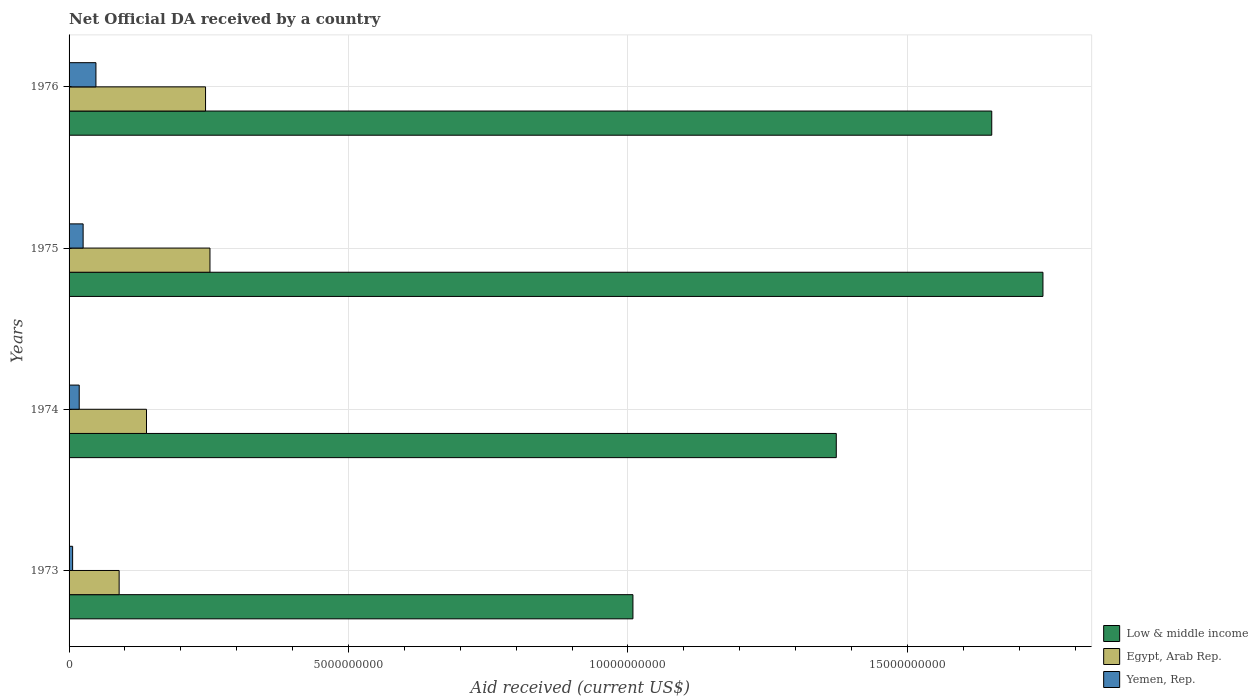How many different coloured bars are there?
Ensure brevity in your answer.  3. How many groups of bars are there?
Keep it short and to the point. 4. Are the number of bars per tick equal to the number of legend labels?
Offer a terse response. Yes. How many bars are there on the 4th tick from the bottom?
Keep it short and to the point. 3. What is the label of the 4th group of bars from the top?
Give a very brief answer. 1973. What is the net official development assistance aid received in Low & middle income in 1975?
Offer a terse response. 1.74e+1. Across all years, what is the maximum net official development assistance aid received in Egypt, Arab Rep.?
Provide a succinct answer. 2.52e+09. Across all years, what is the minimum net official development assistance aid received in Low & middle income?
Provide a short and direct response. 1.01e+1. In which year was the net official development assistance aid received in Egypt, Arab Rep. maximum?
Offer a very short reply. 1975. In which year was the net official development assistance aid received in Egypt, Arab Rep. minimum?
Provide a short and direct response. 1973. What is the total net official development assistance aid received in Low & middle income in the graph?
Ensure brevity in your answer.  5.77e+1. What is the difference between the net official development assistance aid received in Yemen, Rep. in 1974 and that in 1976?
Give a very brief answer. -2.99e+08. What is the difference between the net official development assistance aid received in Egypt, Arab Rep. in 1973 and the net official development assistance aid received in Low & middle income in 1976?
Provide a short and direct response. -1.56e+1. What is the average net official development assistance aid received in Egypt, Arab Rep. per year?
Your answer should be very brief. 1.81e+09. In the year 1973, what is the difference between the net official development assistance aid received in Egypt, Arab Rep. and net official development assistance aid received in Low & middle income?
Your response must be concise. -9.19e+09. In how many years, is the net official development assistance aid received in Low & middle income greater than 6000000000 US$?
Make the answer very short. 4. What is the ratio of the net official development assistance aid received in Yemen, Rep. in 1974 to that in 1975?
Make the answer very short. 0.72. Is the net official development assistance aid received in Yemen, Rep. in 1974 less than that in 1975?
Make the answer very short. Yes. Is the difference between the net official development assistance aid received in Egypt, Arab Rep. in 1974 and 1976 greater than the difference between the net official development assistance aid received in Low & middle income in 1974 and 1976?
Provide a short and direct response. Yes. What is the difference between the highest and the second highest net official development assistance aid received in Yemen, Rep.?
Provide a short and direct response. 2.29e+08. What is the difference between the highest and the lowest net official development assistance aid received in Egypt, Arab Rep.?
Keep it short and to the point. 1.62e+09. In how many years, is the net official development assistance aid received in Yemen, Rep. greater than the average net official development assistance aid received in Yemen, Rep. taken over all years?
Keep it short and to the point. 2. What does the 1st bar from the top in 1973 represents?
Make the answer very short. Yemen, Rep. What does the 1st bar from the bottom in 1973 represents?
Provide a succinct answer. Low & middle income. Does the graph contain grids?
Offer a very short reply. Yes. Where does the legend appear in the graph?
Keep it short and to the point. Bottom right. How are the legend labels stacked?
Offer a very short reply. Vertical. What is the title of the graph?
Offer a terse response. Net Official DA received by a country. What is the label or title of the X-axis?
Offer a very short reply. Aid received (current US$). What is the label or title of the Y-axis?
Your answer should be very brief. Years. What is the Aid received (current US$) of Low & middle income in 1973?
Offer a very short reply. 1.01e+1. What is the Aid received (current US$) of Egypt, Arab Rep. in 1973?
Ensure brevity in your answer.  8.96e+08. What is the Aid received (current US$) of Yemen, Rep. in 1973?
Your answer should be very brief. 6.36e+07. What is the Aid received (current US$) in Low & middle income in 1974?
Provide a short and direct response. 1.37e+1. What is the Aid received (current US$) in Egypt, Arab Rep. in 1974?
Offer a terse response. 1.39e+09. What is the Aid received (current US$) in Yemen, Rep. in 1974?
Your answer should be very brief. 1.82e+08. What is the Aid received (current US$) of Low & middle income in 1975?
Provide a short and direct response. 1.74e+1. What is the Aid received (current US$) in Egypt, Arab Rep. in 1975?
Make the answer very short. 2.52e+09. What is the Aid received (current US$) of Yemen, Rep. in 1975?
Make the answer very short. 2.51e+08. What is the Aid received (current US$) of Low & middle income in 1976?
Provide a succinct answer. 1.65e+1. What is the Aid received (current US$) of Egypt, Arab Rep. in 1976?
Provide a succinct answer. 2.44e+09. What is the Aid received (current US$) in Yemen, Rep. in 1976?
Provide a succinct answer. 4.81e+08. Across all years, what is the maximum Aid received (current US$) of Low & middle income?
Offer a very short reply. 1.74e+1. Across all years, what is the maximum Aid received (current US$) of Egypt, Arab Rep.?
Offer a terse response. 2.52e+09. Across all years, what is the maximum Aid received (current US$) of Yemen, Rep.?
Your answer should be very brief. 4.81e+08. Across all years, what is the minimum Aid received (current US$) in Low & middle income?
Your response must be concise. 1.01e+1. Across all years, what is the minimum Aid received (current US$) in Egypt, Arab Rep.?
Ensure brevity in your answer.  8.96e+08. Across all years, what is the minimum Aid received (current US$) in Yemen, Rep.?
Provide a succinct answer. 6.36e+07. What is the total Aid received (current US$) in Low & middle income in the graph?
Provide a short and direct response. 5.77e+1. What is the total Aid received (current US$) in Egypt, Arab Rep. in the graph?
Give a very brief answer. 7.24e+09. What is the total Aid received (current US$) of Yemen, Rep. in the graph?
Give a very brief answer. 9.77e+08. What is the difference between the Aid received (current US$) in Low & middle income in 1973 and that in 1974?
Your answer should be very brief. -3.64e+09. What is the difference between the Aid received (current US$) in Egypt, Arab Rep. in 1973 and that in 1974?
Ensure brevity in your answer.  -4.89e+08. What is the difference between the Aid received (current US$) of Yemen, Rep. in 1973 and that in 1974?
Give a very brief answer. -1.18e+08. What is the difference between the Aid received (current US$) in Low & middle income in 1973 and that in 1975?
Make the answer very short. -7.34e+09. What is the difference between the Aid received (current US$) in Egypt, Arab Rep. in 1973 and that in 1975?
Your response must be concise. -1.62e+09. What is the difference between the Aid received (current US$) in Yemen, Rep. in 1973 and that in 1975?
Provide a succinct answer. -1.88e+08. What is the difference between the Aid received (current US$) of Low & middle income in 1973 and that in 1976?
Offer a very short reply. -6.42e+09. What is the difference between the Aid received (current US$) in Egypt, Arab Rep. in 1973 and that in 1976?
Make the answer very short. -1.55e+09. What is the difference between the Aid received (current US$) in Yemen, Rep. in 1973 and that in 1976?
Offer a very short reply. -4.17e+08. What is the difference between the Aid received (current US$) in Low & middle income in 1974 and that in 1975?
Your answer should be compact. -3.70e+09. What is the difference between the Aid received (current US$) in Egypt, Arab Rep. in 1974 and that in 1975?
Give a very brief answer. -1.14e+09. What is the difference between the Aid received (current US$) in Yemen, Rep. in 1974 and that in 1975?
Offer a very short reply. -6.97e+07. What is the difference between the Aid received (current US$) in Low & middle income in 1974 and that in 1976?
Make the answer very short. -2.78e+09. What is the difference between the Aid received (current US$) of Egypt, Arab Rep. in 1974 and that in 1976?
Offer a terse response. -1.06e+09. What is the difference between the Aid received (current US$) in Yemen, Rep. in 1974 and that in 1976?
Offer a terse response. -2.99e+08. What is the difference between the Aid received (current US$) of Low & middle income in 1975 and that in 1976?
Ensure brevity in your answer.  9.16e+08. What is the difference between the Aid received (current US$) in Egypt, Arab Rep. in 1975 and that in 1976?
Give a very brief answer. 7.89e+07. What is the difference between the Aid received (current US$) in Yemen, Rep. in 1975 and that in 1976?
Your response must be concise. -2.29e+08. What is the difference between the Aid received (current US$) in Low & middle income in 1973 and the Aid received (current US$) in Egypt, Arab Rep. in 1974?
Ensure brevity in your answer.  8.70e+09. What is the difference between the Aid received (current US$) in Low & middle income in 1973 and the Aid received (current US$) in Yemen, Rep. in 1974?
Keep it short and to the point. 9.91e+09. What is the difference between the Aid received (current US$) of Egypt, Arab Rep. in 1973 and the Aid received (current US$) of Yemen, Rep. in 1974?
Ensure brevity in your answer.  7.14e+08. What is the difference between the Aid received (current US$) in Low & middle income in 1973 and the Aid received (current US$) in Egypt, Arab Rep. in 1975?
Your answer should be compact. 7.57e+09. What is the difference between the Aid received (current US$) of Low & middle income in 1973 and the Aid received (current US$) of Yemen, Rep. in 1975?
Provide a short and direct response. 9.84e+09. What is the difference between the Aid received (current US$) in Egypt, Arab Rep. in 1973 and the Aid received (current US$) in Yemen, Rep. in 1975?
Your answer should be compact. 6.45e+08. What is the difference between the Aid received (current US$) in Low & middle income in 1973 and the Aid received (current US$) in Egypt, Arab Rep. in 1976?
Make the answer very short. 7.65e+09. What is the difference between the Aid received (current US$) in Low & middle income in 1973 and the Aid received (current US$) in Yemen, Rep. in 1976?
Provide a succinct answer. 9.61e+09. What is the difference between the Aid received (current US$) of Egypt, Arab Rep. in 1973 and the Aid received (current US$) of Yemen, Rep. in 1976?
Your answer should be very brief. 4.15e+08. What is the difference between the Aid received (current US$) of Low & middle income in 1974 and the Aid received (current US$) of Egypt, Arab Rep. in 1975?
Provide a short and direct response. 1.12e+1. What is the difference between the Aid received (current US$) of Low & middle income in 1974 and the Aid received (current US$) of Yemen, Rep. in 1975?
Provide a short and direct response. 1.35e+1. What is the difference between the Aid received (current US$) in Egypt, Arab Rep. in 1974 and the Aid received (current US$) in Yemen, Rep. in 1975?
Offer a very short reply. 1.13e+09. What is the difference between the Aid received (current US$) in Low & middle income in 1974 and the Aid received (current US$) in Egypt, Arab Rep. in 1976?
Give a very brief answer. 1.13e+1. What is the difference between the Aid received (current US$) of Low & middle income in 1974 and the Aid received (current US$) of Yemen, Rep. in 1976?
Offer a terse response. 1.32e+1. What is the difference between the Aid received (current US$) in Egypt, Arab Rep. in 1974 and the Aid received (current US$) in Yemen, Rep. in 1976?
Your answer should be very brief. 9.05e+08. What is the difference between the Aid received (current US$) in Low & middle income in 1975 and the Aid received (current US$) in Egypt, Arab Rep. in 1976?
Offer a terse response. 1.50e+1. What is the difference between the Aid received (current US$) in Low & middle income in 1975 and the Aid received (current US$) in Yemen, Rep. in 1976?
Offer a very short reply. 1.69e+1. What is the difference between the Aid received (current US$) in Egypt, Arab Rep. in 1975 and the Aid received (current US$) in Yemen, Rep. in 1976?
Ensure brevity in your answer.  2.04e+09. What is the average Aid received (current US$) in Low & middle income per year?
Your response must be concise. 1.44e+1. What is the average Aid received (current US$) in Egypt, Arab Rep. per year?
Your answer should be very brief. 1.81e+09. What is the average Aid received (current US$) in Yemen, Rep. per year?
Your answer should be very brief. 2.44e+08. In the year 1973, what is the difference between the Aid received (current US$) in Low & middle income and Aid received (current US$) in Egypt, Arab Rep.?
Your response must be concise. 9.19e+09. In the year 1973, what is the difference between the Aid received (current US$) of Low & middle income and Aid received (current US$) of Yemen, Rep.?
Make the answer very short. 1.00e+1. In the year 1973, what is the difference between the Aid received (current US$) of Egypt, Arab Rep. and Aid received (current US$) of Yemen, Rep.?
Provide a succinct answer. 8.32e+08. In the year 1974, what is the difference between the Aid received (current US$) in Low & middle income and Aid received (current US$) in Egypt, Arab Rep.?
Offer a terse response. 1.23e+1. In the year 1974, what is the difference between the Aid received (current US$) in Low & middle income and Aid received (current US$) in Yemen, Rep.?
Provide a succinct answer. 1.35e+1. In the year 1974, what is the difference between the Aid received (current US$) of Egypt, Arab Rep. and Aid received (current US$) of Yemen, Rep.?
Offer a very short reply. 1.20e+09. In the year 1975, what is the difference between the Aid received (current US$) in Low & middle income and Aid received (current US$) in Egypt, Arab Rep.?
Offer a terse response. 1.49e+1. In the year 1975, what is the difference between the Aid received (current US$) in Low & middle income and Aid received (current US$) in Yemen, Rep.?
Offer a very short reply. 1.72e+1. In the year 1975, what is the difference between the Aid received (current US$) of Egypt, Arab Rep. and Aid received (current US$) of Yemen, Rep.?
Your answer should be very brief. 2.27e+09. In the year 1976, what is the difference between the Aid received (current US$) of Low & middle income and Aid received (current US$) of Egypt, Arab Rep.?
Your response must be concise. 1.41e+1. In the year 1976, what is the difference between the Aid received (current US$) in Low & middle income and Aid received (current US$) in Yemen, Rep.?
Offer a terse response. 1.60e+1. In the year 1976, what is the difference between the Aid received (current US$) of Egypt, Arab Rep. and Aid received (current US$) of Yemen, Rep.?
Your response must be concise. 1.96e+09. What is the ratio of the Aid received (current US$) of Low & middle income in 1973 to that in 1974?
Give a very brief answer. 0.73. What is the ratio of the Aid received (current US$) in Egypt, Arab Rep. in 1973 to that in 1974?
Ensure brevity in your answer.  0.65. What is the ratio of the Aid received (current US$) in Low & middle income in 1973 to that in 1975?
Your answer should be compact. 0.58. What is the ratio of the Aid received (current US$) of Egypt, Arab Rep. in 1973 to that in 1975?
Your answer should be compact. 0.36. What is the ratio of the Aid received (current US$) in Yemen, Rep. in 1973 to that in 1975?
Offer a terse response. 0.25. What is the ratio of the Aid received (current US$) in Low & middle income in 1973 to that in 1976?
Give a very brief answer. 0.61. What is the ratio of the Aid received (current US$) in Egypt, Arab Rep. in 1973 to that in 1976?
Your answer should be very brief. 0.37. What is the ratio of the Aid received (current US$) of Yemen, Rep. in 1973 to that in 1976?
Keep it short and to the point. 0.13. What is the ratio of the Aid received (current US$) of Low & middle income in 1974 to that in 1975?
Offer a very short reply. 0.79. What is the ratio of the Aid received (current US$) in Egypt, Arab Rep. in 1974 to that in 1975?
Make the answer very short. 0.55. What is the ratio of the Aid received (current US$) of Yemen, Rep. in 1974 to that in 1975?
Offer a very short reply. 0.72. What is the ratio of the Aid received (current US$) in Low & middle income in 1974 to that in 1976?
Offer a terse response. 0.83. What is the ratio of the Aid received (current US$) in Egypt, Arab Rep. in 1974 to that in 1976?
Your answer should be compact. 0.57. What is the ratio of the Aid received (current US$) of Yemen, Rep. in 1974 to that in 1976?
Keep it short and to the point. 0.38. What is the ratio of the Aid received (current US$) in Low & middle income in 1975 to that in 1976?
Keep it short and to the point. 1.06. What is the ratio of the Aid received (current US$) of Egypt, Arab Rep. in 1975 to that in 1976?
Ensure brevity in your answer.  1.03. What is the ratio of the Aid received (current US$) in Yemen, Rep. in 1975 to that in 1976?
Your answer should be compact. 0.52. What is the difference between the highest and the second highest Aid received (current US$) in Low & middle income?
Make the answer very short. 9.16e+08. What is the difference between the highest and the second highest Aid received (current US$) in Egypt, Arab Rep.?
Provide a short and direct response. 7.89e+07. What is the difference between the highest and the second highest Aid received (current US$) in Yemen, Rep.?
Provide a succinct answer. 2.29e+08. What is the difference between the highest and the lowest Aid received (current US$) in Low & middle income?
Offer a very short reply. 7.34e+09. What is the difference between the highest and the lowest Aid received (current US$) in Egypt, Arab Rep.?
Offer a terse response. 1.62e+09. What is the difference between the highest and the lowest Aid received (current US$) in Yemen, Rep.?
Keep it short and to the point. 4.17e+08. 